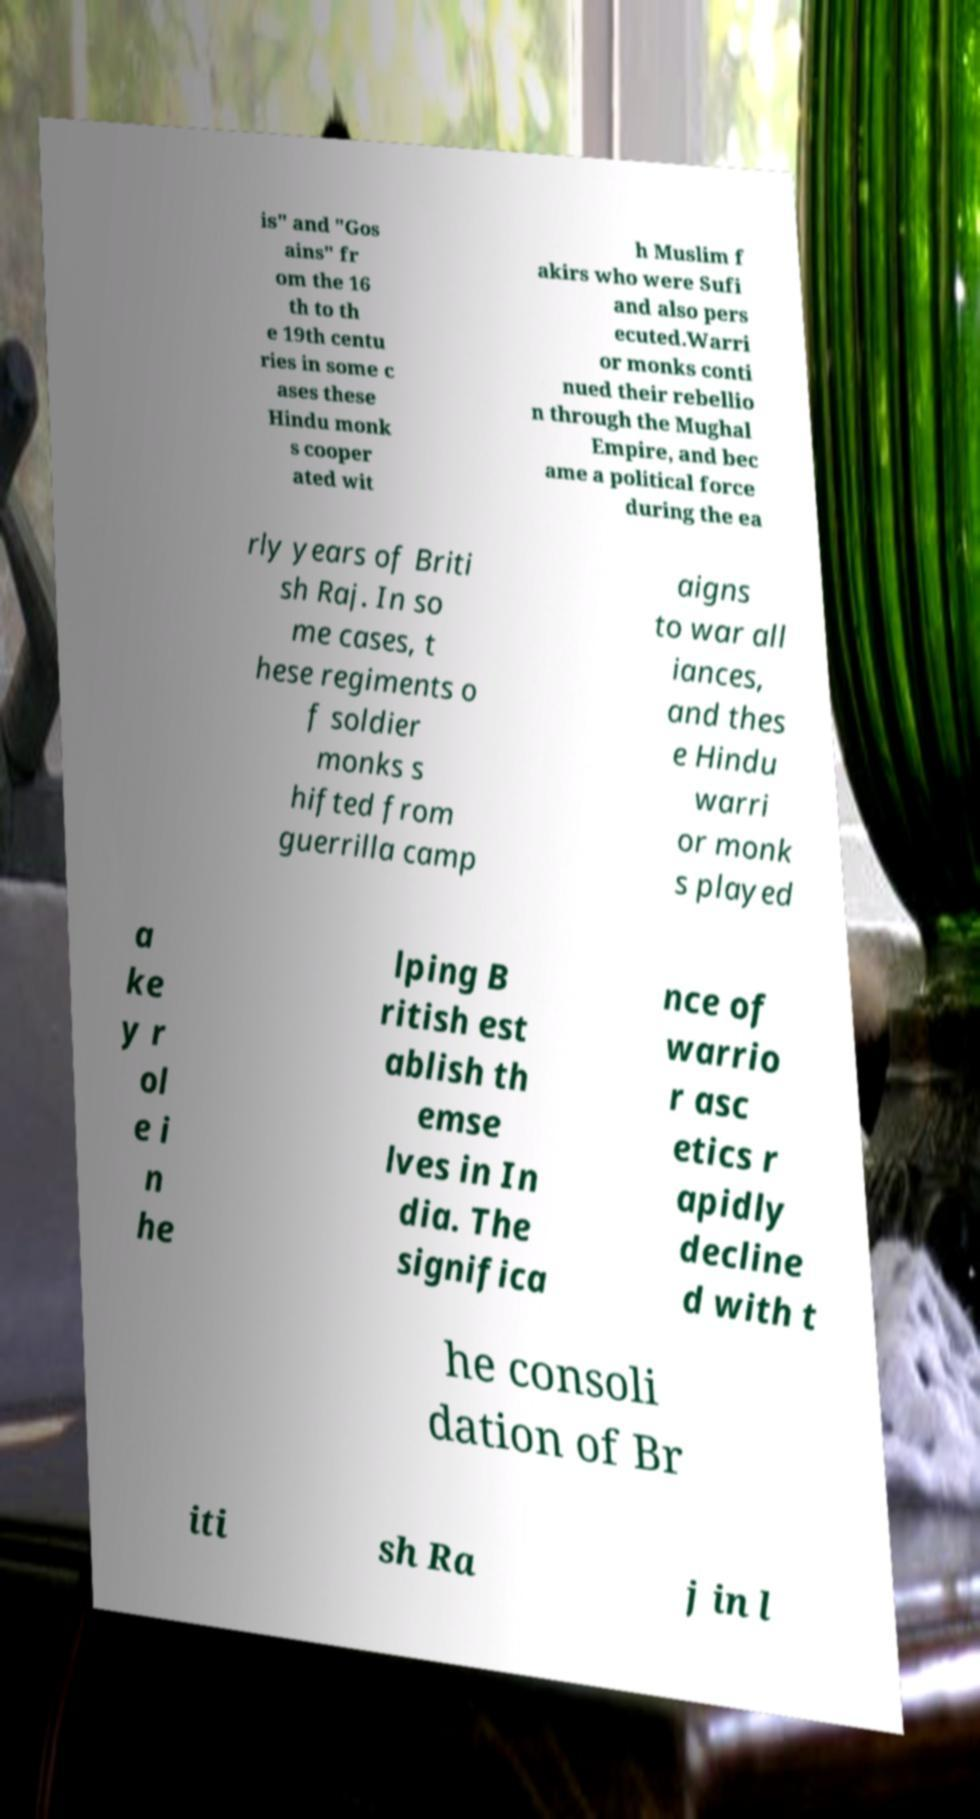Please identify and transcribe the text found in this image. is" and "Gos ains" fr om the 16 th to th e 19th centu ries in some c ases these Hindu monk s cooper ated wit h Muslim f akirs who were Sufi and also pers ecuted.Warri or monks conti nued their rebellio n through the Mughal Empire, and bec ame a political force during the ea rly years of Briti sh Raj. In so me cases, t hese regiments o f soldier monks s hifted from guerrilla camp aigns to war all iances, and thes e Hindu warri or monk s played a ke y r ol e i n he lping B ritish est ablish th emse lves in In dia. The significa nce of warrio r asc etics r apidly decline d with t he consoli dation of Br iti sh Ra j in l 